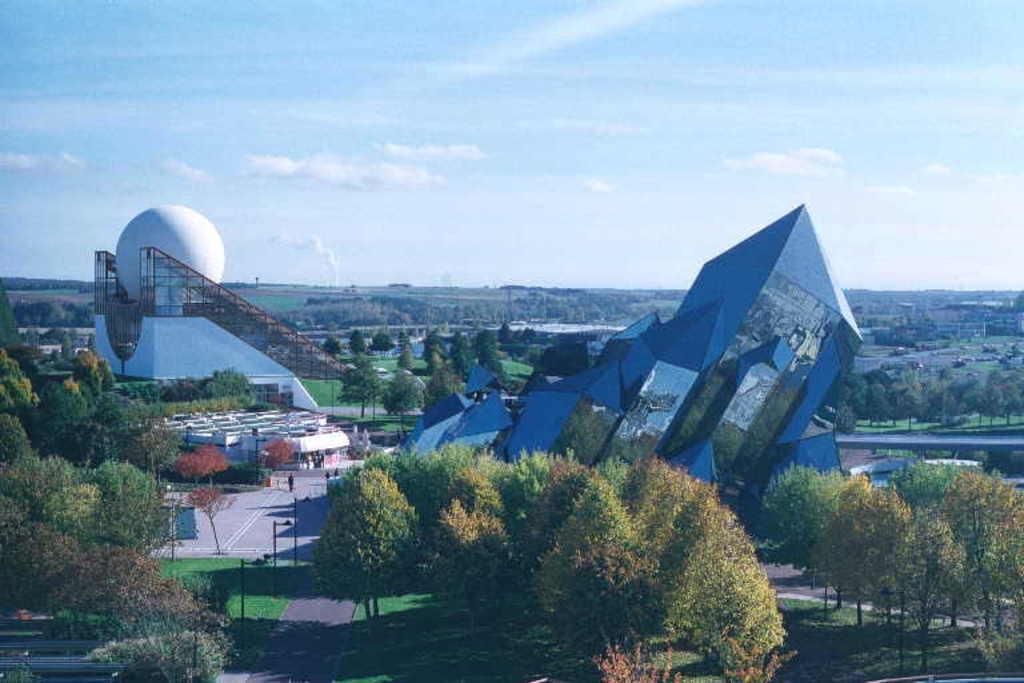Can you describe this image briefly? In this image there are trees and architectures and the sky. 